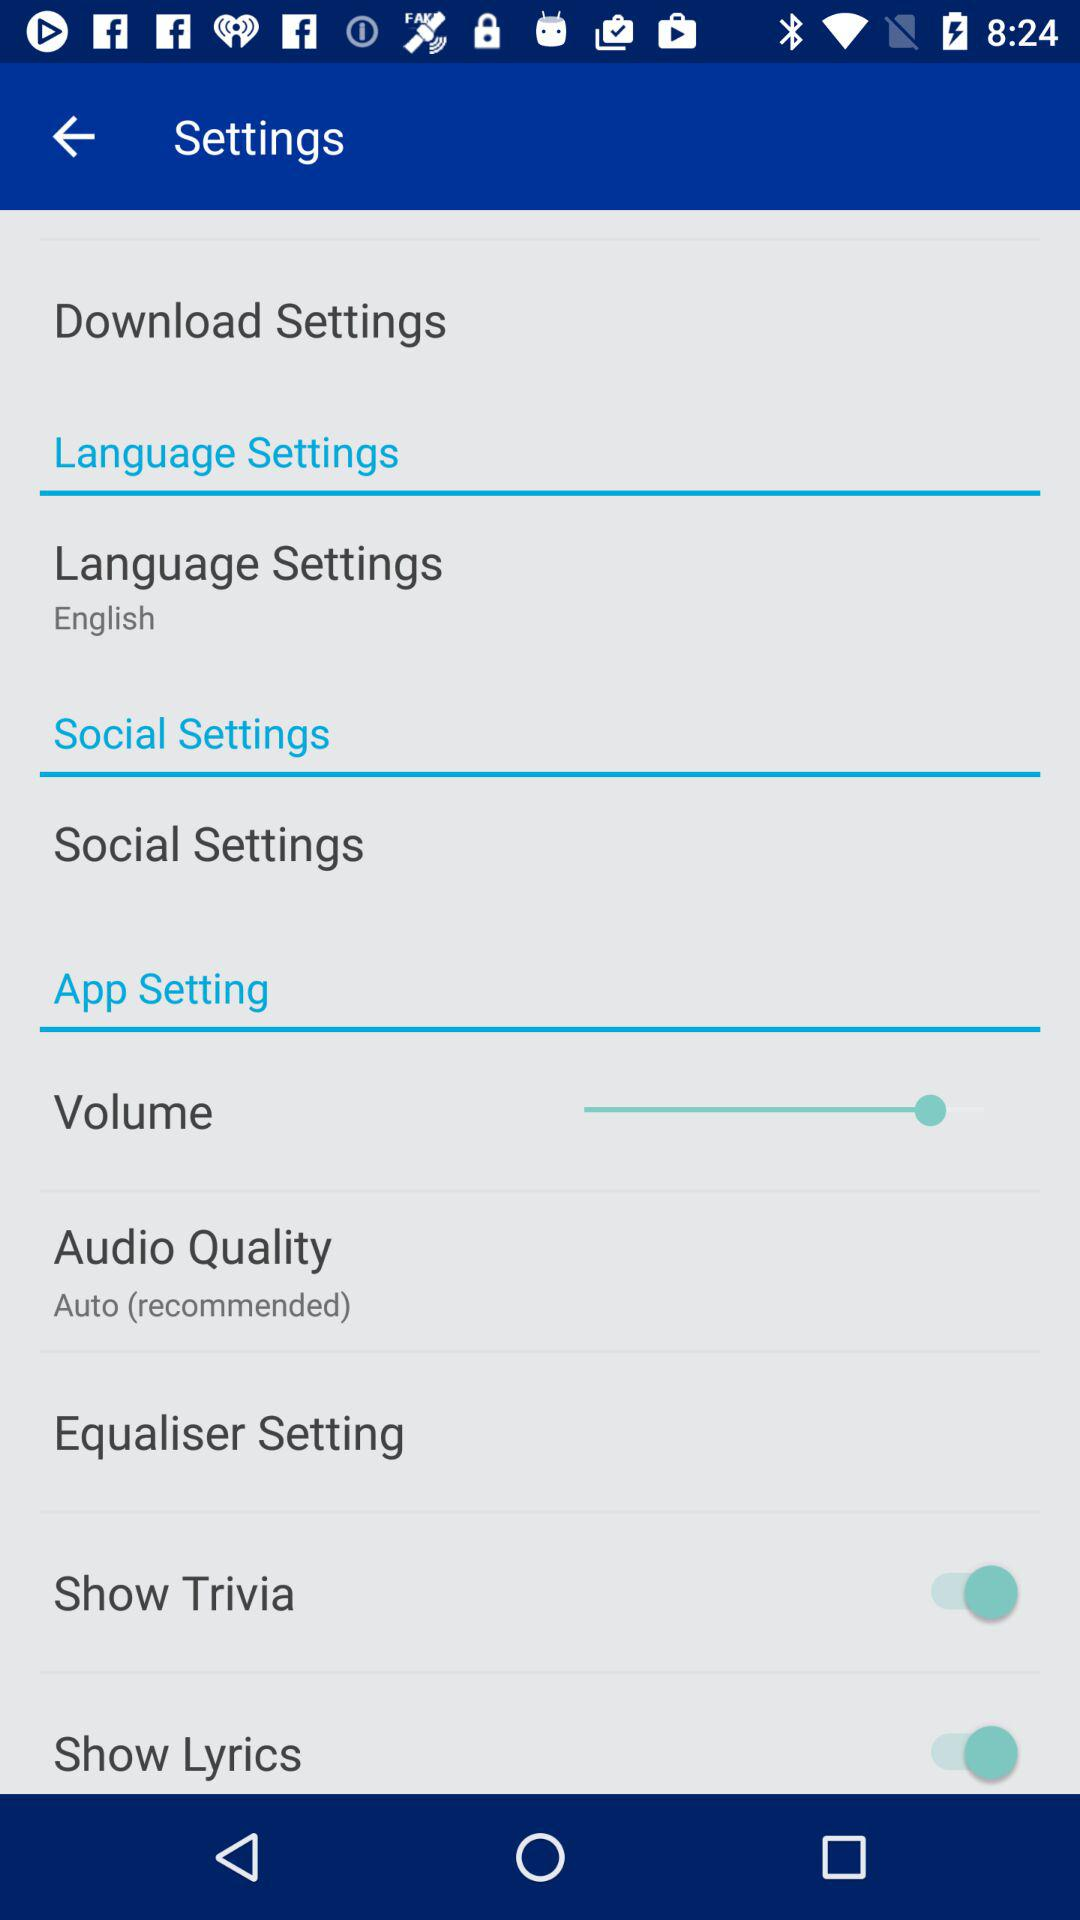What is the status of "Show Lyrics"? The status is "on". 